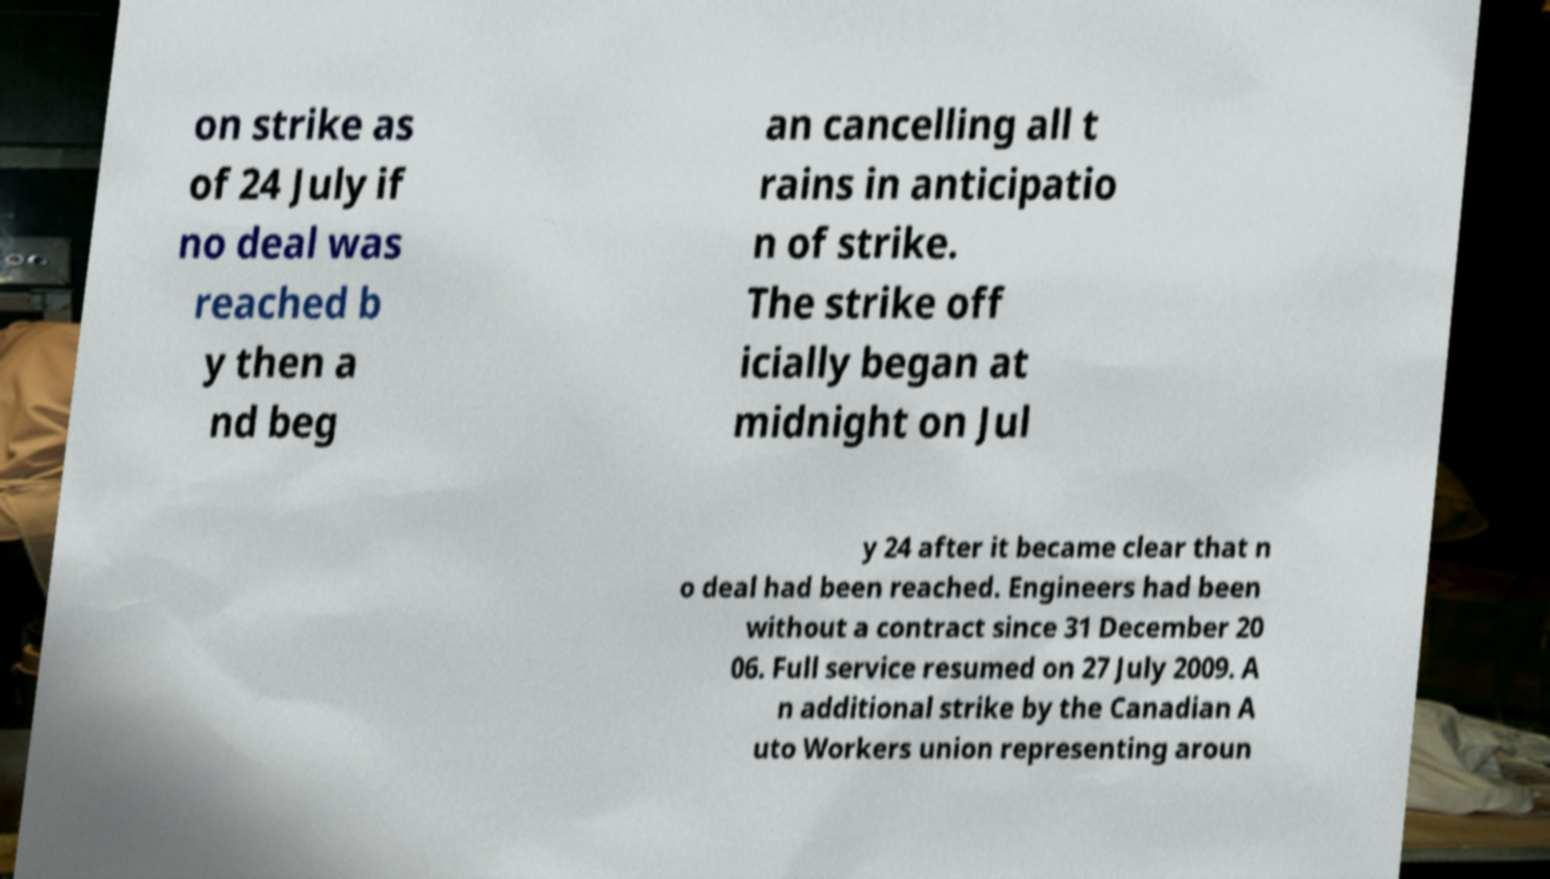I need the written content from this picture converted into text. Can you do that? on strike as of 24 July if no deal was reached b y then a nd beg an cancelling all t rains in anticipatio n of strike. The strike off icially began at midnight on Jul y 24 after it became clear that n o deal had been reached. Engineers had been without a contract since 31 December 20 06. Full service resumed on 27 July 2009. A n additional strike by the Canadian A uto Workers union representing aroun 